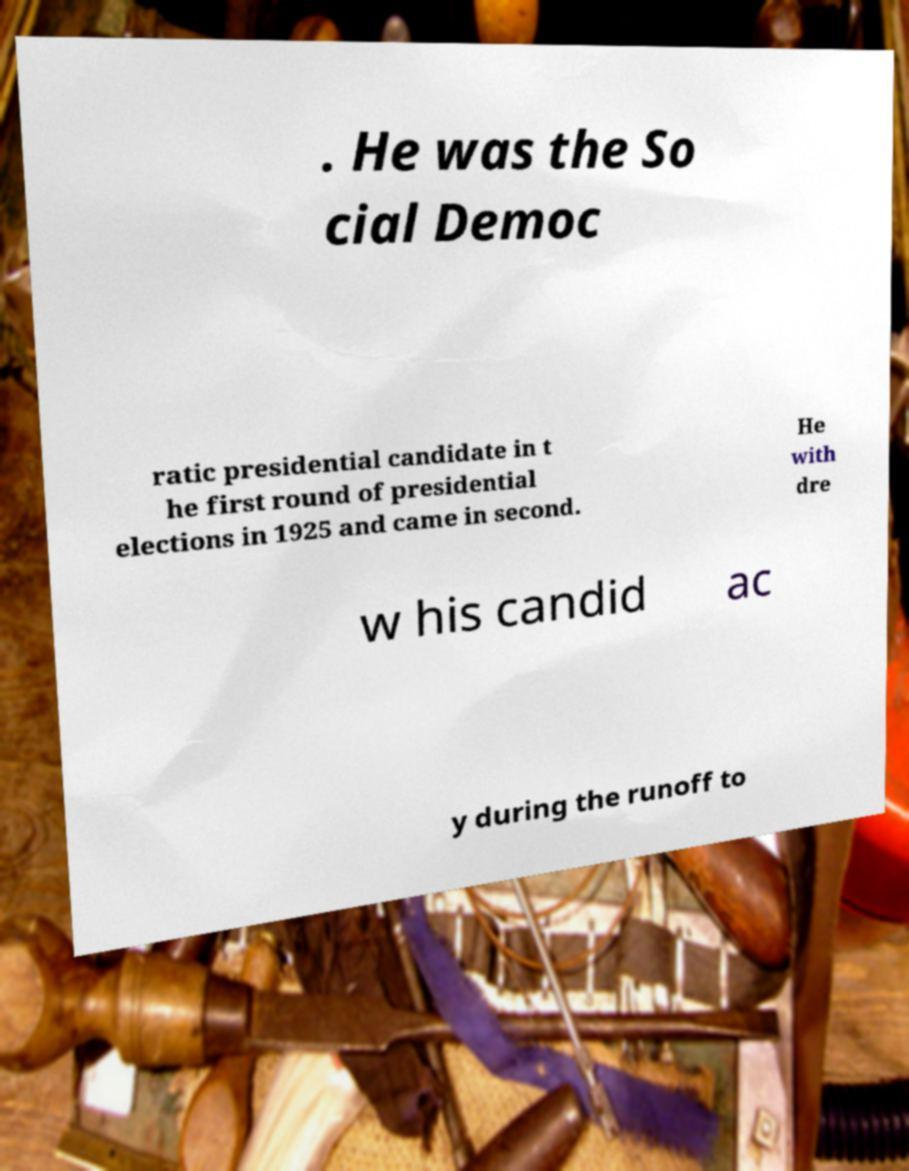Please identify and transcribe the text found in this image. . He was the So cial Democ ratic presidential candidate in t he first round of presidential elections in 1925 and came in second. He with dre w his candid ac y during the runoff to 